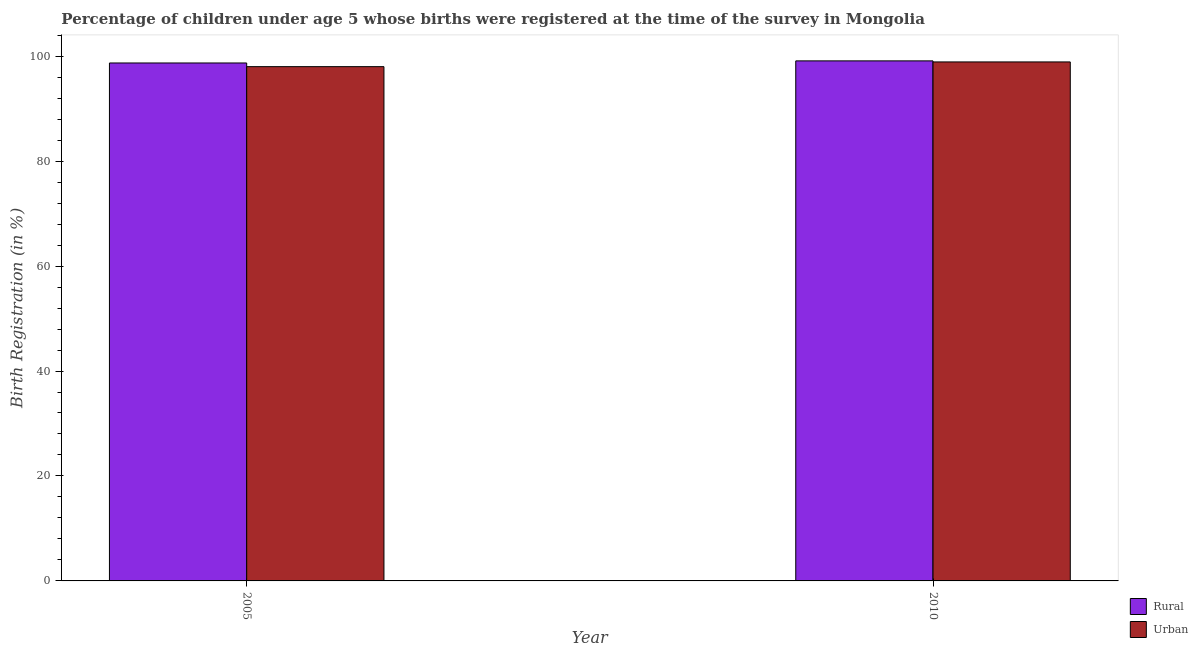How many groups of bars are there?
Give a very brief answer. 2. Are the number of bars on each tick of the X-axis equal?
Offer a very short reply. Yes. How many bars are there on the 1st tick from the right?
Ensure brevity in your answer.  2. What is the label of the 2nd group of bars from the left?
Keep it short and to the point. 2010. What is the rural birth registration in 2005?
Your answer should be compact. 98.7. Across all years, what is the maximum urban birth registration?
Offer a very short reply. 98.9. Across all years, what is the minimum rural birth registration?
Provide a succinct answer. 98.7. What is the total rural birth registration in the graph?
Provide a succinct answer. 197.8. What is the difference between the rural birth registration in 2005 and that in 2010?
Give a very brief answer. -0.4. What is the difference between the rural birth registration in 2005 and the urban birth registration in 2010?
Keep it short and to the point. -0.4. What is the average rural birth registration per year?
Your answer should be very brief. 98.9. What is the ratio of the rural birth registration in 2005 to that in 2010?
Your answer should be compact. 1. In how many years, is the urban birth registration greater than the average urban birth registration taken over all years?
Provide a succinct answer. 1. What does the 2nd bar from the left in 2010 represents?
Your answer should be compact. Urban. What does the 1st bar from the right in 2005 represents?
Your response must be concise. Urban. Are all the bars in the graph horizontal?
Offer a very short reply. No. How many years are there in the graph?
Your answer should be very brief. 2. Does the graph contain any zero values?
Give a very brief answer. No. What is the title of the graph?
Offer a terse response. Percentage of children under age 5 whose births were registered at the time of the survey in Mongolia. Does "Quasi money growth" appear as one of the legend labels in the graph?
Make the answer very short. No. What is the label or title of the X-axis?
Offer a terse response. Year. What is the label or title of the Y-axis?
Offer a terse response. Birth Registration (in %). What is the Birth Registration (in %) in Rural in 2005?
Offer a terse response. 98.7. What is the Birth Registration (in %) of Rural in 2010?
Offer a terse response. 99.1. What is the Birth Registration (in %) of Urban in 2010?
Provide a short and direct response. 98.9. Across all years, what is the maximum Birth Registration (in %) in Rural?
Give a very brief answer. 99.1. Across all years, what is the maximum Birth Registration (in %) in Urban?
Your response must be concise. 98.9. Across all years, what is the minimum Birth Registration (in %) of Rural?
Your response must be concise. 98.7. What is the total Birth Registration (in %) of Rural in the graph?
Offer a very short reply. 197.8. What is the total Birth Registration (in %) of Urban in the graph?
Your answer should be very brief. 196.9. What is the difference between the Birth Registration (in %) in Urban in 2005 and that in 2010?
Offer a very short reply. -0.9. What is the difference between the Birth Registration (in %) in Rural in 2005 and the Birth Registration (in %) in Urban in 2010?
Offer a terse response. -0.2. What is the average Birth Registration (in %) in Rural per year?
Your answer should be compact. 98.9. What is the average Birth Registration (in %) in Urban per year?
Provide a succinct answer. 98.45. In the year 2010, what is the difference between the Birth Registration (in %) in Rural and Birth Registration (in %) in Urban?
Your answer should be compact. 0.2. What is the ratio of the Birth Registration (in %) of Urban in 2005 to that in 2010?
Ensure brevity in your answer.  0.99. 